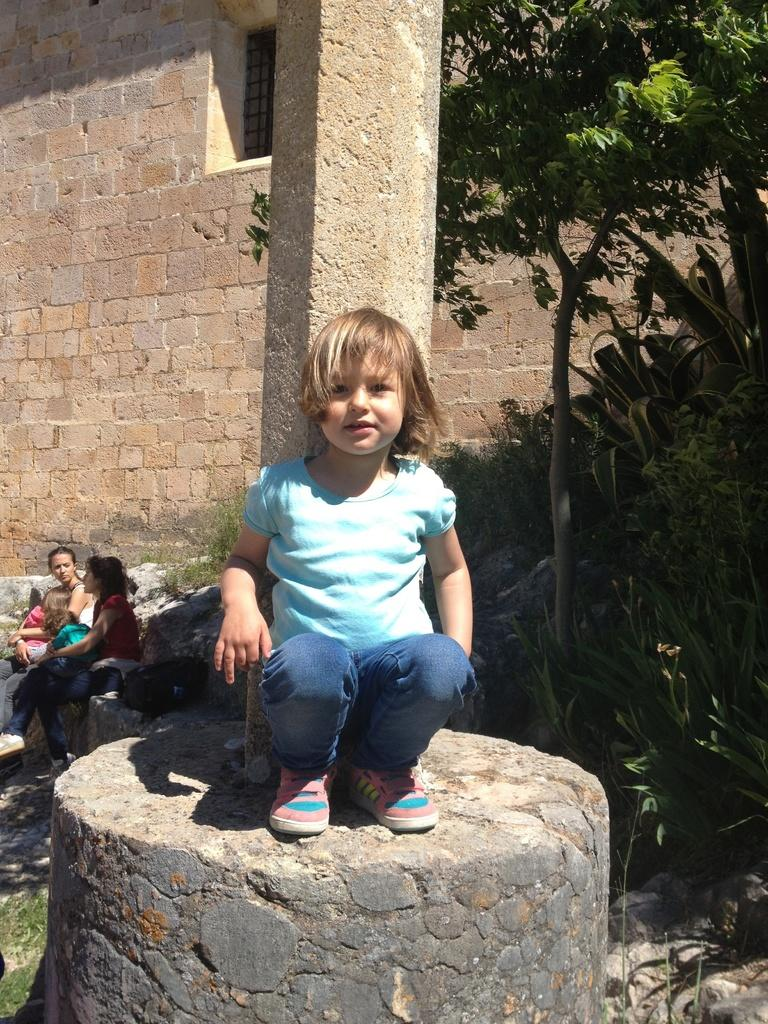Who is the main subject in the image? There is a girl in the middle of the image. What can be seen on the right side of the image? There are trees on the right side of the image. What are the people in the image doing? There are persons sitting on the left side of the image. What is visible in the background of the image? There is a wall in the background of the image. Finally, we describe the sky's condition, which is clear, to give a sense of the weather or time of day. Can you tell me how many forks are being used by the girl in the image? There is no fork present in the image; the girl is not using any utensils. What type of space vehicle can be seen in the image? There is no space vehicle present in the image; it is a scene with a girl, trees, sitting persons, and a wall in the background. 